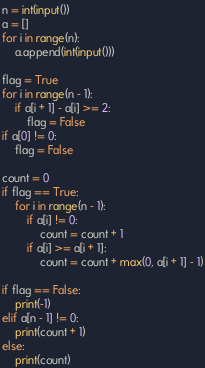<code> <loc_0><loc_0><loc_500><loc_500><_Python_>n = int(input())
a = []
for i in range(n):
    a.append(int(input()))

flag = True
for i in range(n - 1):
    if a[i + 1] - a[i] >= 2:
        flag = False
if a[0] != 0:
    flag = False

count = 0
if flag == True:
    for i in range(n - 1):
        if a[i] != 0:
            count = count + 1
        if a[i] >= a[i + 1]:
            count = count + max(0, a[i + 1] - 1)
   
if flag == False:
    print(-1)
elif a[n - 1] != 0:
    print(count + 1)
else:
    print(count)</code> 